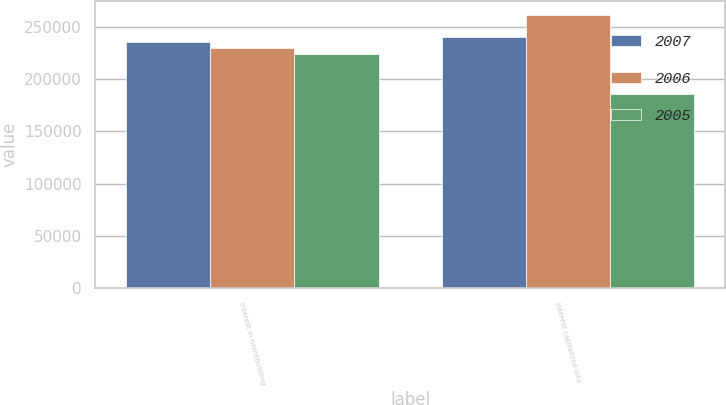Convert chart to OTSL. <chart><loc_0><loc_0><loc_500><loc_500><stacked_bar_chart><ecel><fcel>Interest in homebuilding<fcel>Interest capitalized into<nl><fcel>2007<fcel>235596<fcel>240000<nl><fcel>2006<fcel>229798<fcel>261486<nl><fcel>2005<fcel>223591<fcel>185792<nl></chart> 